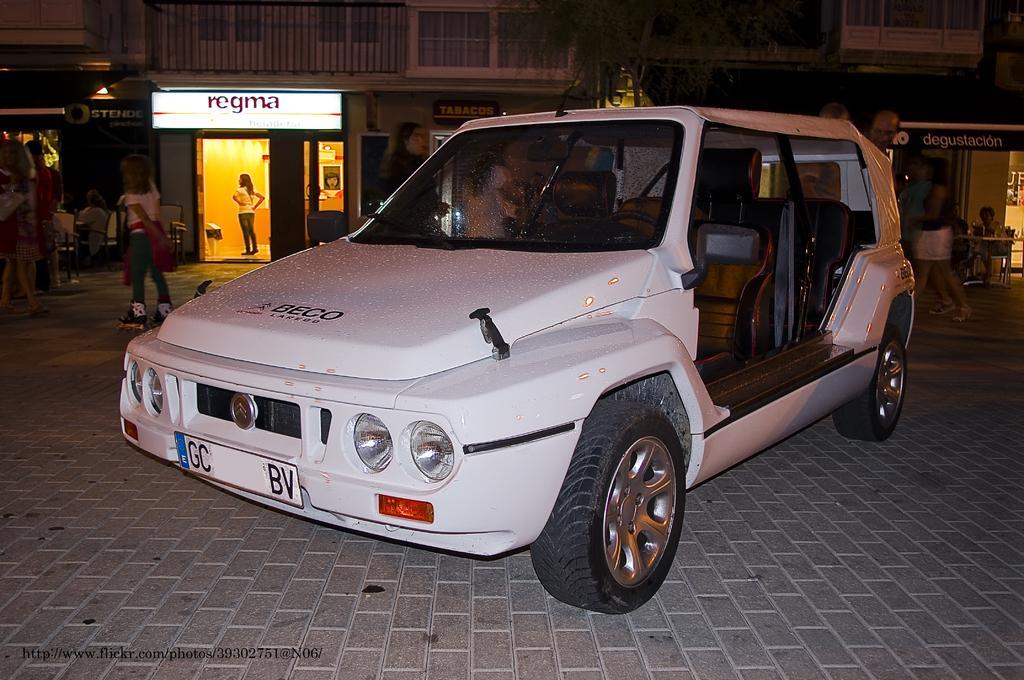In one or two sentences, can you explain what this image depicts? In this image I can see a white car with headlights,wheels and a hood. There are few people standing and sitting. At background I can see a building with a name board. This is a tree. Behind the car I can see few persons walking. 